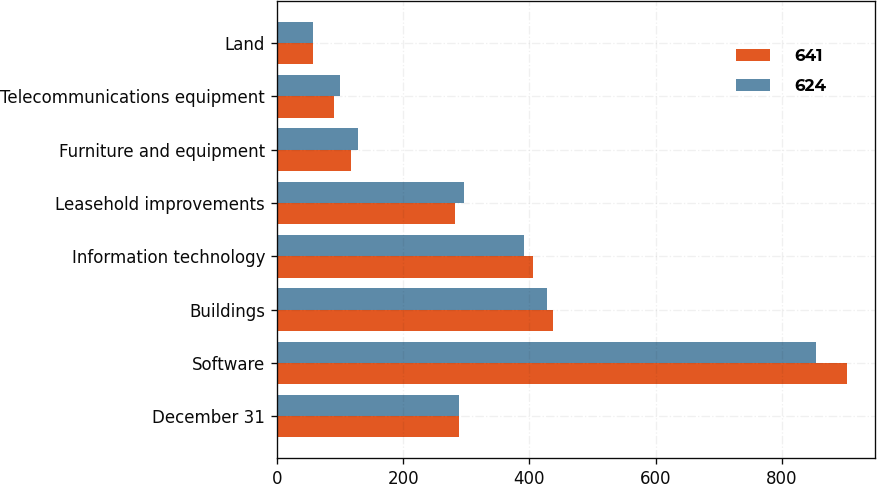Convert chart. <chart><loc_0><loc_0><loc_500><loc_500><stacked_bar_chart><ecel><fcel>December 31<fcel>Software<fcel>Buildings<fcel>Information technology<fcel>Leasehold improvements<fcel>Furniture and equipment<fcel>Telecommunications equipment<fcel>Land<nl><fcel>641<fcel>289<fcel>902<fcel>438<fcel>405<fcel>282<fcel>118<fcel>91<fcel>57<nl><fcel>624<fcel>289<fcel>854<fcel>428<fcel>392<fcel>296<fcel>128<fcel>100<fcel>57<nl></chart> 